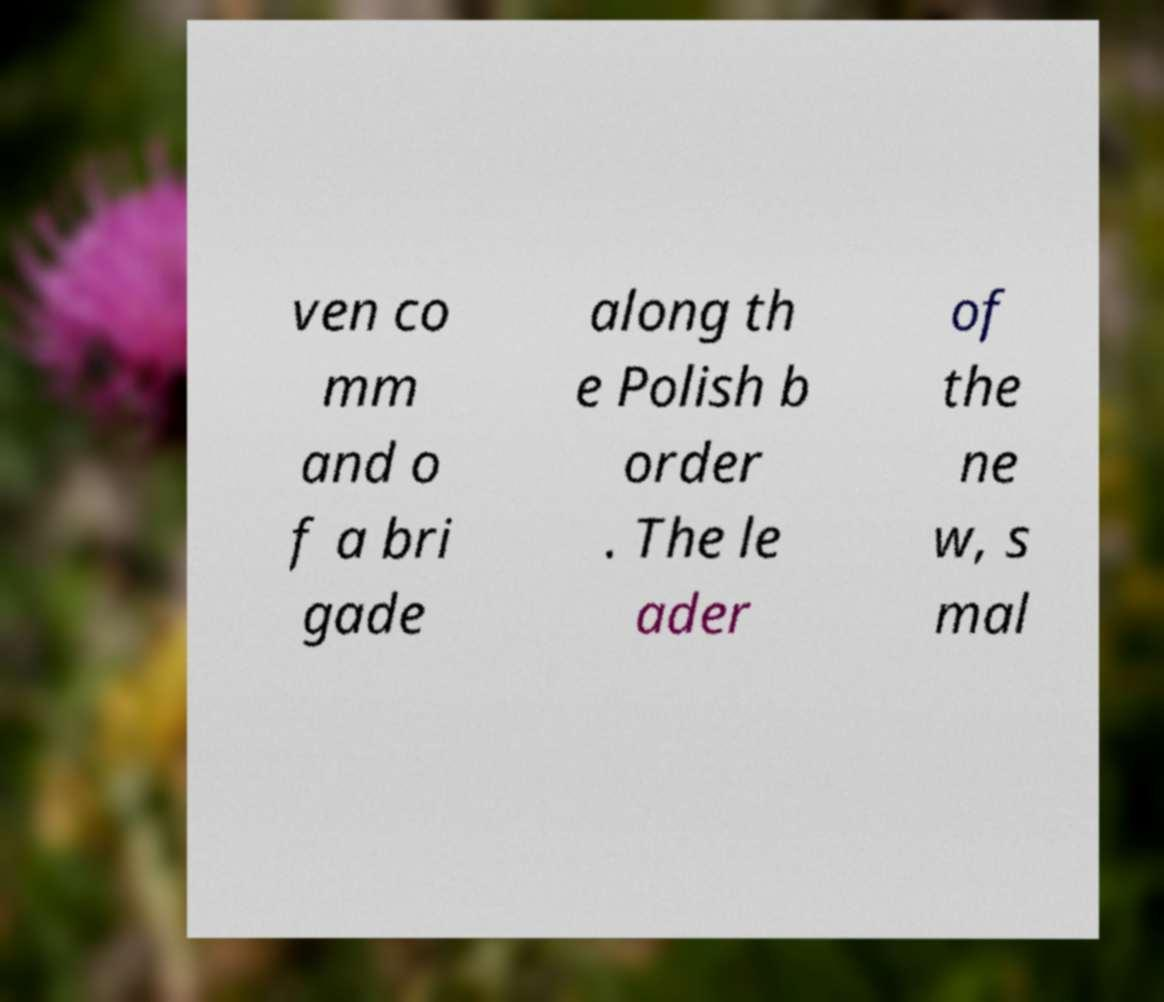Could you extract and type out the text from this image? ven co mm and o f a bri gade along th e Polish b order . The le ader of the ne w, s mal 